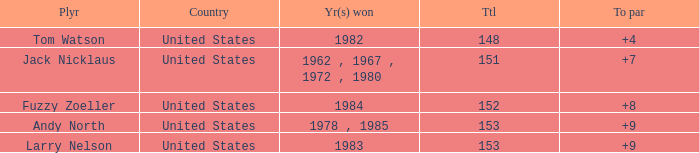What is the Total of the Player with a To par of 4? 1.0. 